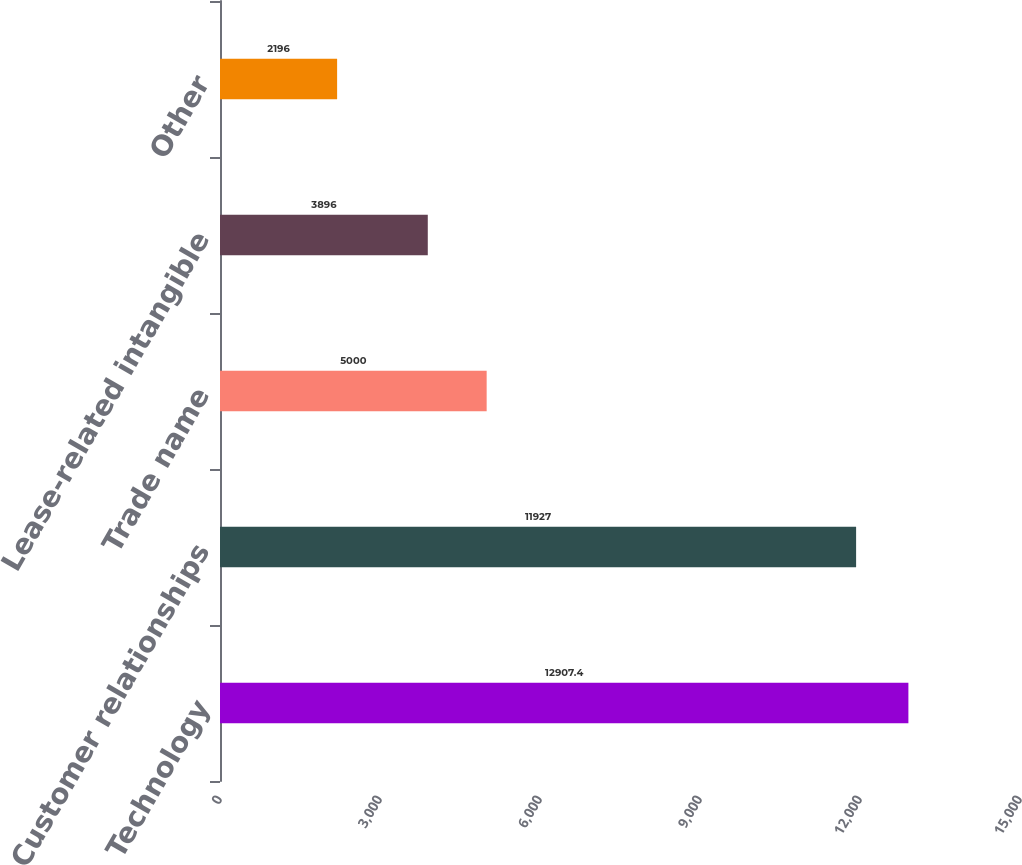<chart> <loc_0><loc_0><loc_500><loc_500><bar_chart><fcel>Technology<fcel>Customer relationships<fcel>Trade name<fcel>Lease-related intangible<fcel>Other<nl><fcel>12907.4<fcel>11927<fcel>5000<fcel>3896<fcel>2196<nl></chart> 